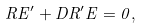Convert formula to latex. <formula><loc_0><loc_0><loc_500><loc_500>R E ^ { \prime } + D R ^ { \prime } E = 0 ,</formula> 